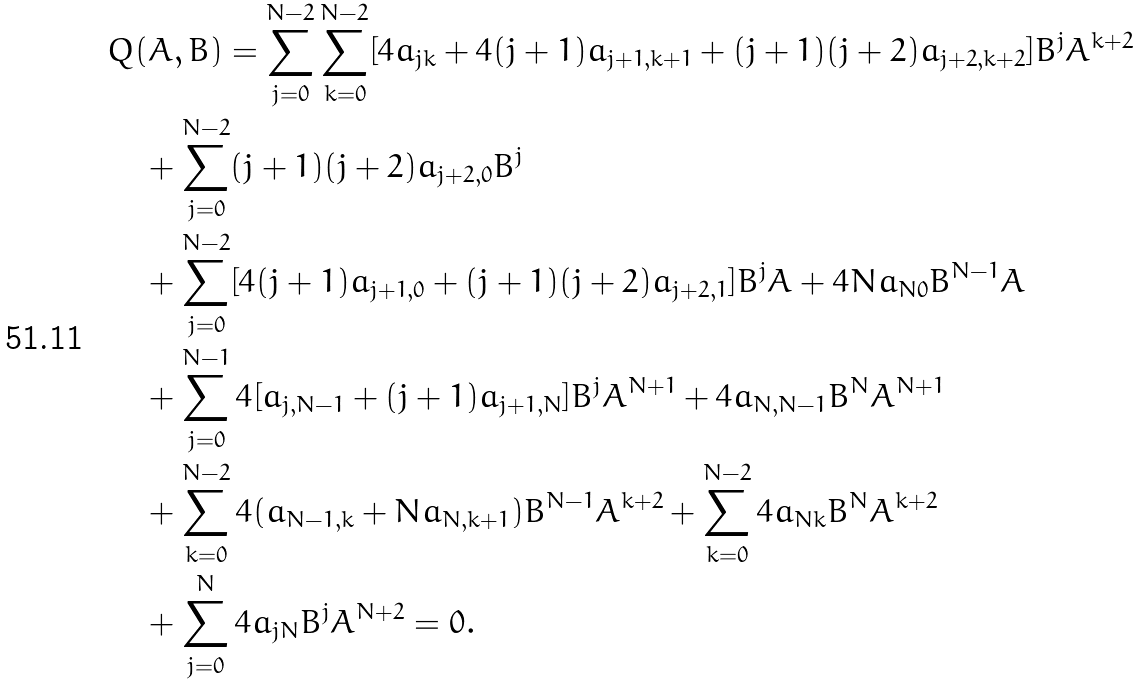<formula> <loc_0><loc_0><loc_500><loc_500>& Q ( A , B ) = \sum _ { j = 0 } ^ { N - 2 } \sum _ { k = 0 } ^ { N - 2 } [ 4 a _ { j k } + 4 ( j + 1 ) a _ { j + 1 , k + 1 } + ( j + 1 ) ( j + 2 ) a _ { j + 2 , k + 2 } ] B ^ { j } A ^ { k + 2 } \\ & \quad + \sum _ { j = 0 } ^ { N - 2 } ( j + 1 ) ( j + 2 ) a _ { j + 2 , 0 } B ^ { j } \\ & \quad + \sum _ { j = 0 } ^ { N - 2 } [ 4 ( j + 1 ) a _ { j + 1 , 0 } + ( j + 1 ) ( j + 2 ) a _ { j + 2 , 1 } ] B ^ { j } A + 4 N a _ { N 0 } B ^ { N - 1 } A \\ & \quad + \sum _ { j = 0 } ^ { N - 1 } 4 [ a _ { j , N - 1 } + ( j + 1 ) a _ { j + 1 , N } ] B ^ { j } A ^ { N + 1 } + 4 a _ { N , N - 1 } B ^ { N } A ^ { N + 1 } \\ & \quad + \sum _ { k = 0 } ^ { N - 2 } 4 ( a _ { N - 1 , k } + N a _ { N , k + 1 } ) B ^ { N - 1 } A ^ { k + 2 } + \sum _ { k = 0 } ^ { N - 2 } 4 a _ { N k } B ^ { N } A ^ { k + 2 } \\ & \quad + \sum _ { j = 0 } ^ { N } 4 a _ { j N } B ^ { j } A ^ { N + 2 } = 0 .</formula> 